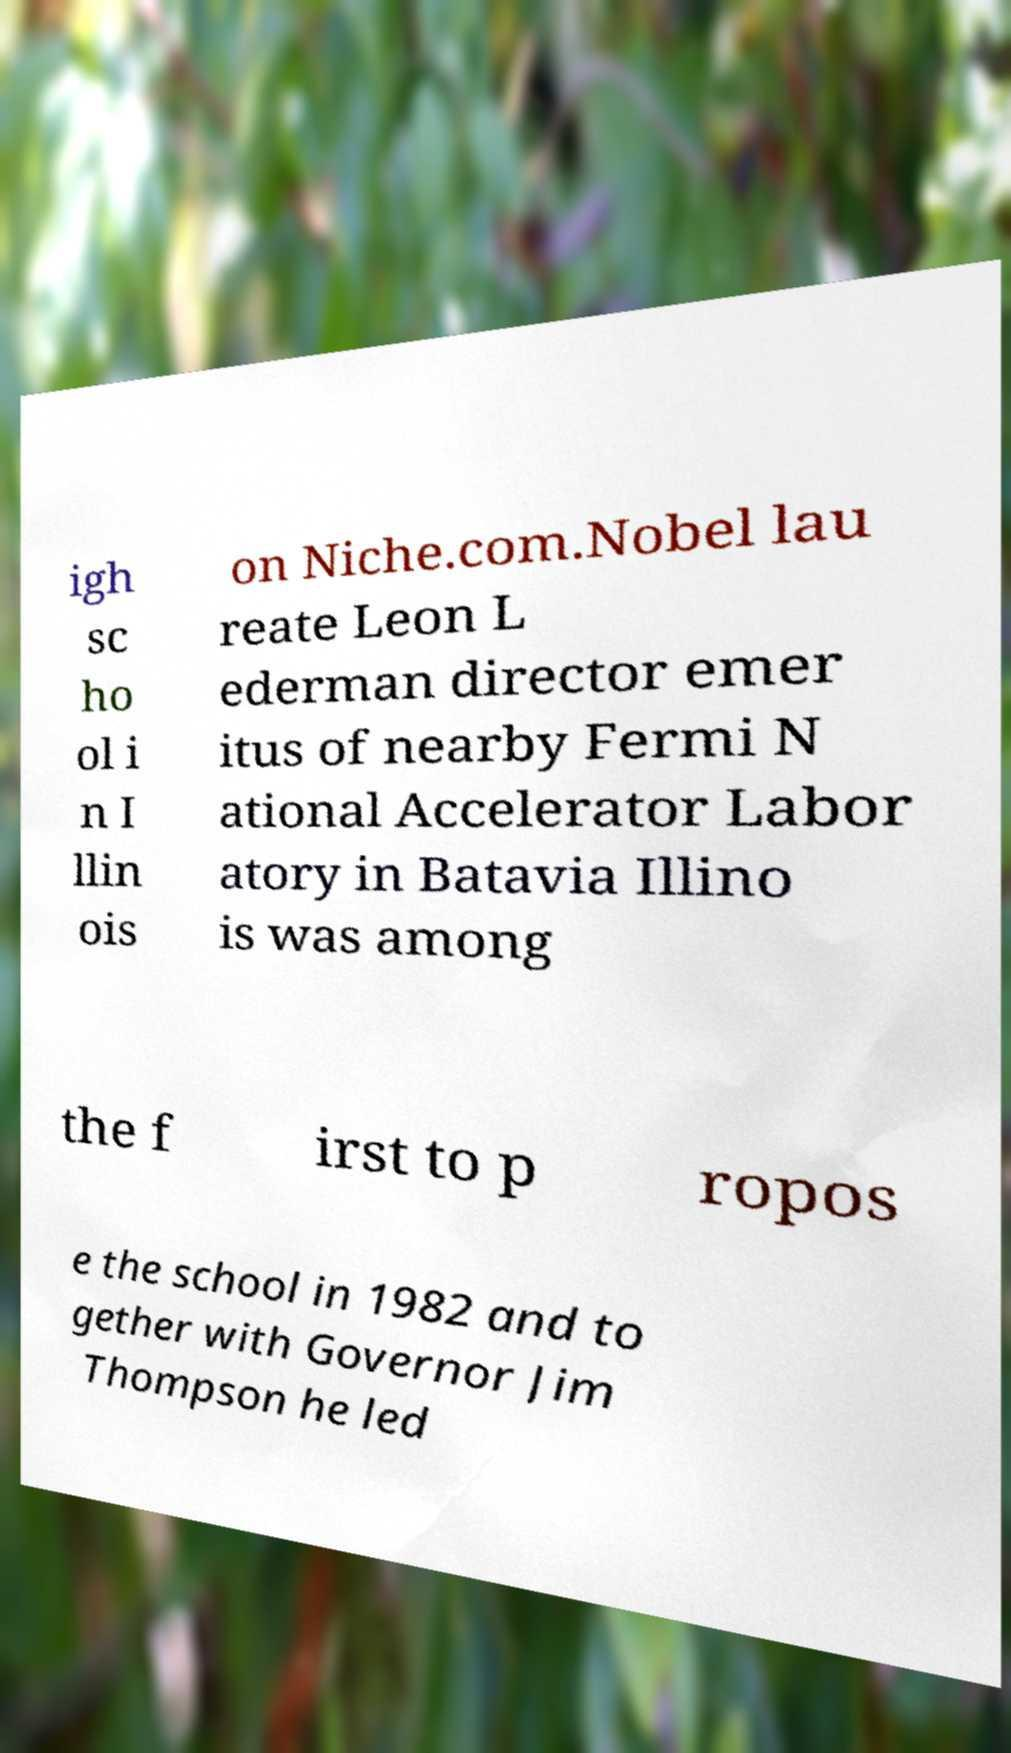Can you accurately transcribe the text from the provided image for me? igh sc ho ol i n I llin ois on Niche.com.Nobel lau reate Leon L ederman director emer itus of nearby Fermi N ational Accelerator Labor atory in Batavia Illino is was among the f irst to p ropos e the school in 1982 and to gether with Governor Jim Thompson he led 